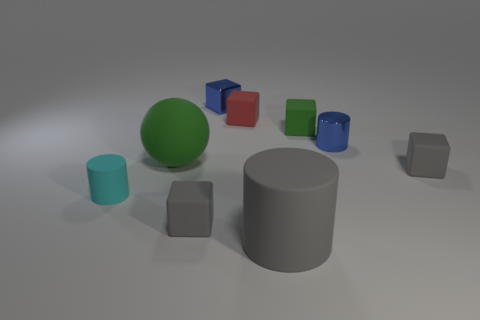How would you describe the position of the small blue block in relation to the grey cylinder? The small blue block is situated to the right of the grey cylinder when viewed from the camera's perspective. It appears to be aligned diagonally from the cylinder's edge, creating a perceptual pathway or a line of sight between the two objects. And what about the green ball? Where is it placed compared to the blue block? The green ball is placed to the left of the blue block. It is positioned closer to the foreground as opposed to the blue block, which seems to lay further back in the scene, implying that the green ball is more towards the front from the viewer's perspective. 